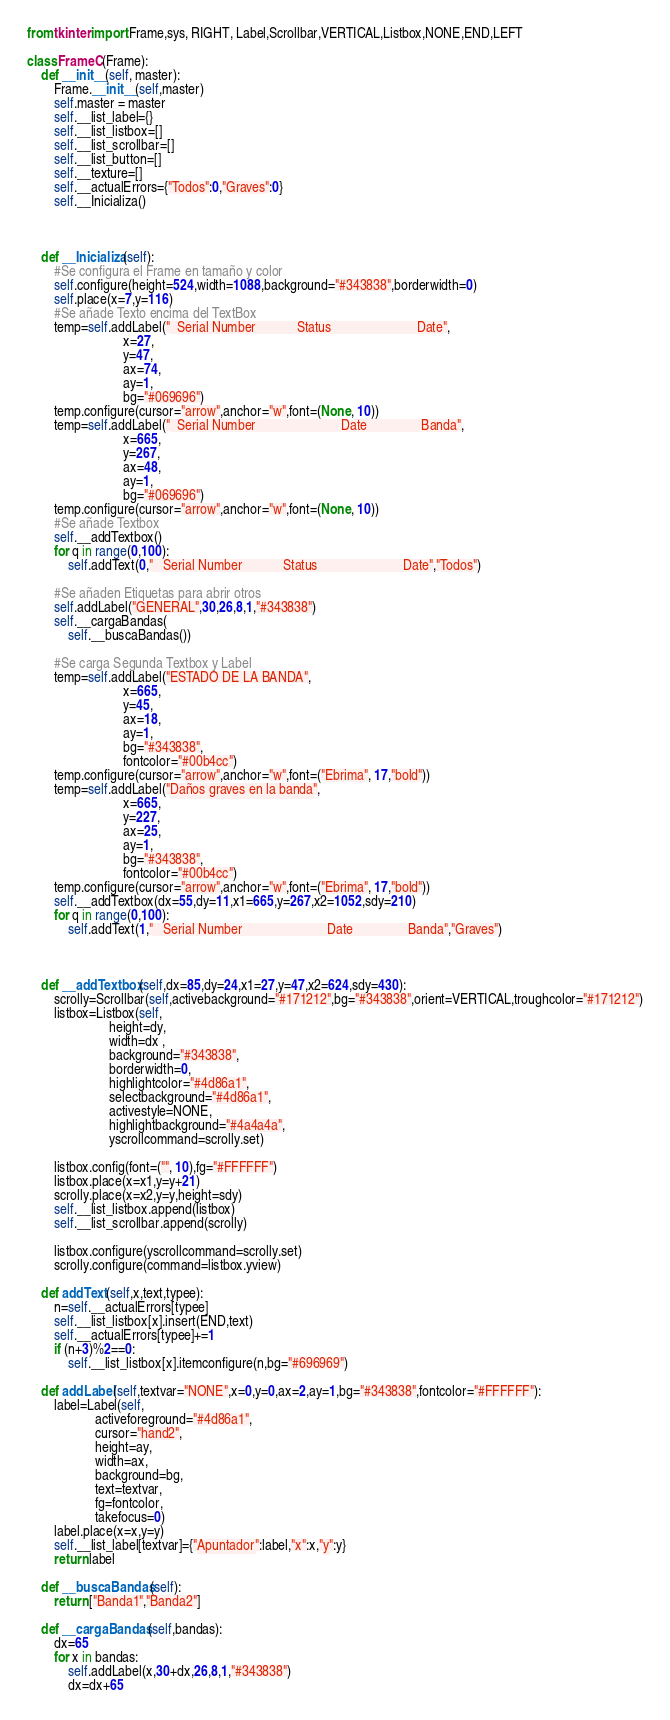<code> <loc_0><loc_0><loc_500><loc_500><_Python_>from tkinter import Frame,sys, RIGHT, Label,Scrollbar,VERTICAL,Listbox,NONE,END,LEFT

class FrameC(Frame):
	def __init__(self, master):
		Frame.__init__(self,master)
		self.master = master
		self.__list_label={}
		self.__list_listbox=[]
		self.__list_scrollbar=[]
		self.__list_button=[]
		self.__texture=[]
		self.__actualErrors={"Todos":0,"Graves":0}
		self.__Inicializa()
		

		
	def __Inicializa(self):
		#Se configura el Frame en tamaño y color
		self.configure(height=524,width=1088,background="#343838",borderwidth=0)
		self.place(x=7,y=116)
		#Se añade Texto encima del TextBox
		temp=self.addLabel("  Serial Number            Status                         Date",
							x=27,
							y=47,
							ax=74,
							ay=1,
							bg="#069696")
		temp.configure(cursor="arrow",anchor="w",font=(None, 10))
		temp=self.addLabel("  Serial Number                         Date                Banda",
							x=665,
							y=267,
							ax=48,
							ay=1,
							bg="#069696")
		temp.configure(cursor="arrow",anchor="w",font=(None, 10))
		#Se añade Textbox
		self.__addTextbox()
		for q in range(0,100):
			self.addText(0,"   Serial Number            Status                         Date","Todos")
		
		#Se añaden Etiquetas para abrir otros
		self.addLabel("GENERAL",30,26,8,1,"#343838")
		self.__cargaBandas(
			self.__buscaBandas())

		#Se carga Segunda Textbox y Label
		temp=self.addLabel("ESTADO DE LA BANDA",
							x=665,
							y=45,
							ax=18,
							ay=1,
							bg="#343838",
							fontcolor="#00b4cc")
		temp.configure(cursor="arrow",anchor="w",font=("Ebrima", 17,"bold"))
		temp=self.addLabel("Daños graves en la banda",
							x=665,
							y=227,
							ax=25,
							ay=1,
							bg="#343838",
							fontcolor="#00b4cc")
		temp.configure(cursor="arrow",anchor="w",font=("Ebrima", 17,"bold"))
		self.__addTextbox(dx=55,dy=11,x1=665,y=267,x2=1052,sdy=210)
		for q in range(0,100):
			self.addText(1,"   Serial Number                         Date                Banda","Graves")



	def __addTextbox(self,dx=85,dy=24,x1=27,y=47,x2=624,sdy=430):
		scrolly=Scrollbar(self,activebackground="#171212",bg="#343838",orient=VERTICAL,troughcolor="#171212")
		listbox=Listbox(self,
						height=dy, 
						width=dx ,
						background="#343838",
						borderwidth=0,
						highlightcolor="#4d86a1",
						selectbackground="#4d86a1",
						activestyle=NONE,
						highlightbackground="#4a4a4a",
						yscrollcommand=scrolly.set)

		listbox.config(font=("", 10),fg="#FFFFFF")
		listbox.place(x=x1,y=y+21)
		scrolly.place(x=x2,y=y,height=sdy)	
		self.__list_listbox.append(listbox)
		self.__list_scrollbar.append(scrolly)
		
		listbox.configure(yscrollcommand=scrolly.set)
		scrolly.configure(command=listbox.yview)

	def addText(self,x,text,typee):
		n=self.__actualErrors[typee]
		self.__list_listbox[x].insert(END,text)
		self.__actualErrors[typee]+=1
		if (n+3)%2==0:
			self.__list_listbox[x].itemconfigure(n,bg="#696969")

	def addLabel(self,textvar="NONE",x=0,y=0,ax=2,ay=1,bg="#343838",fontcolor="#FFFFFF"):
		label=Label(self,
					activeforeground="#4d86a1",
					cursor="hand2",
					height=ay,
					width=ax,
					background=bg,
					text=textvar,
					fg=fontcolor,
					takefocus=0)
		label.place(x=x,y=y)
		self.__list_label[textvar]={"Apuntador":label,"x":x,"y":y}
		return label

	def __buscaBandas(self):
		return ["Banda1","Banda2"]

	def __cargaBandas(self,bandas):
		dx=65
		for x in bandas:
			self.addLabel(x,30+dx,26,8,1,"#343838")
			dx=dx+65</code> 